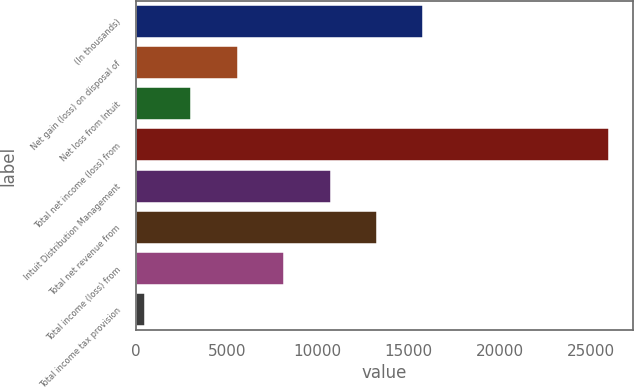<chart> <loc_0><loc_0><loc_500><loc_500><bar_chart><fcel>(In thousands)<fcel>Net gain (loss) on disposal of<fcel>Net loss from Intuit<fcel>Total net income (loss) from<fcel>Intuit Distribution Management<fcel>Total net revenue from<fcel>Total income (loss) from<fcel>Total income tax provision<nl><fcel>15804.4<fcel>5596.8<fcel>3044.9<fcel>26012<fcel>10700.6<fcel>13252.5<fcel>8148.7<fcel>493<nl></chart> 